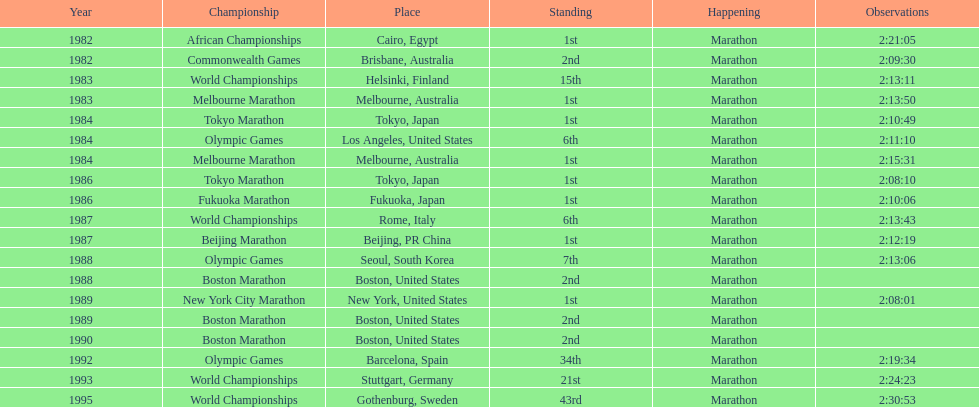What was the first marathon juma ikangaa won? 1982 African Championships. 